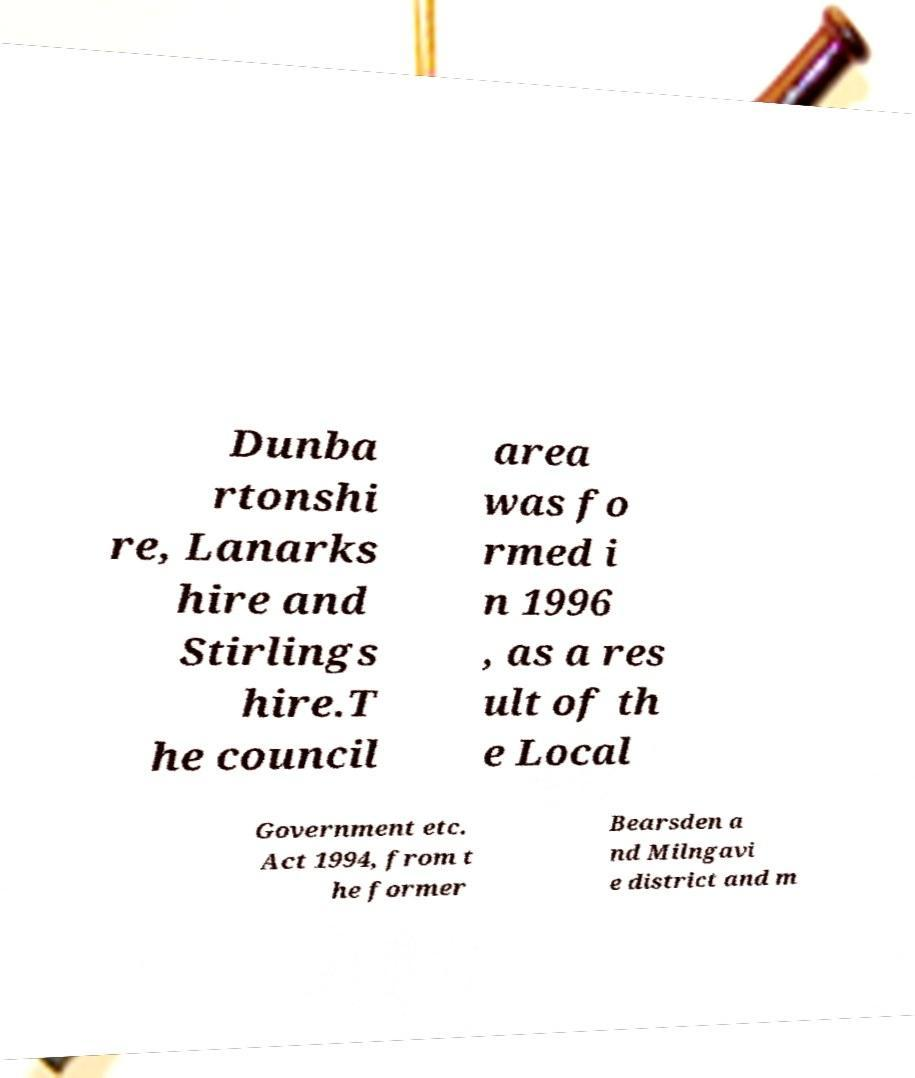Could you assist in decoding the text presented in this image and type it out clearly? Dunba rtonshi re, Lanarks hire and Stirlings hire.T he council area was fo rmed i n 1996 , as a res ult of th e Local Government etc. Act 1994, from t he former Bearsden a nd Milngavi e district and m 